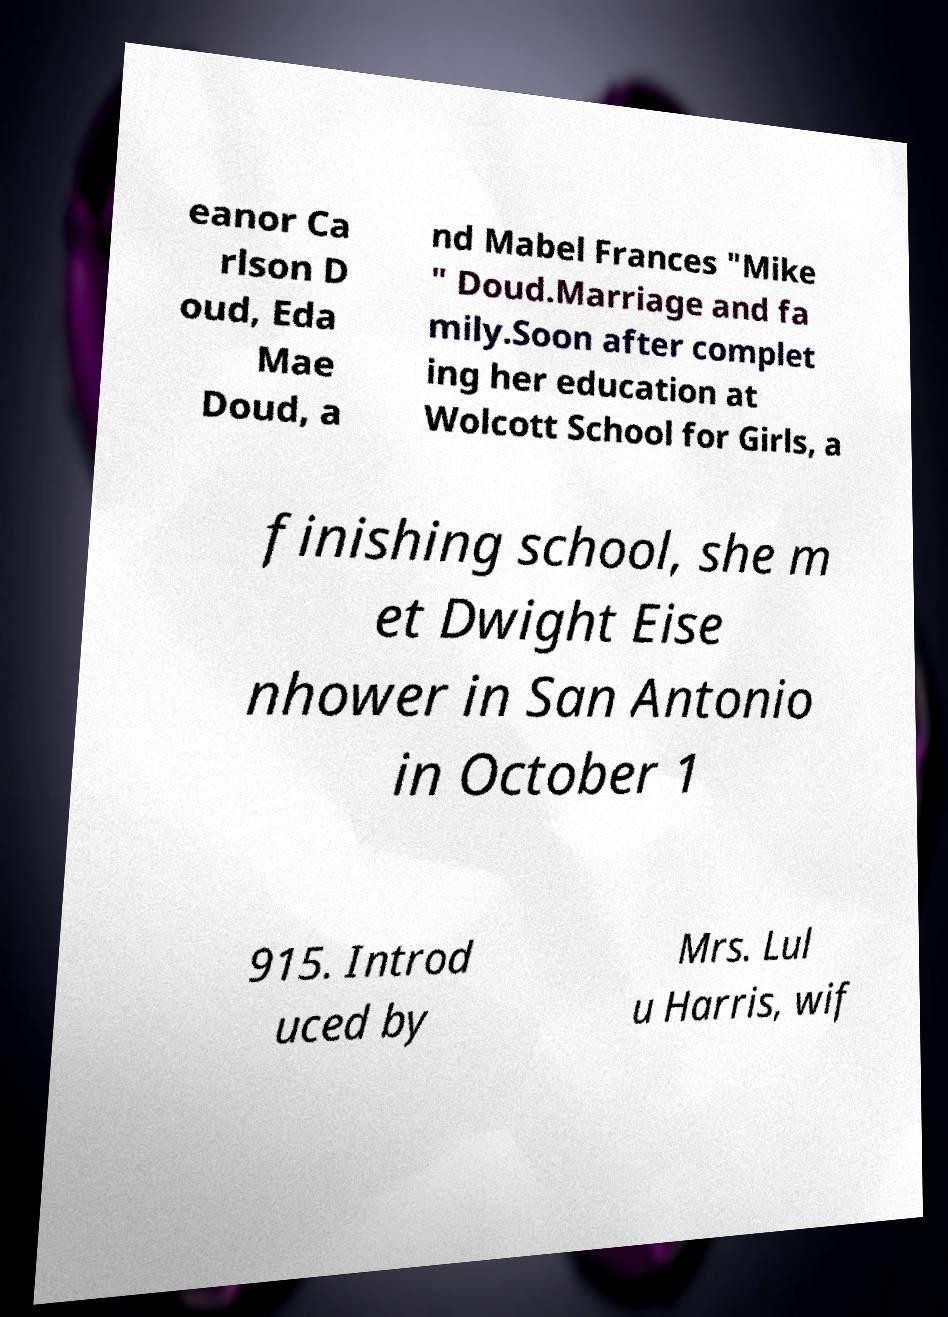Can you accurately transcribe the text from the provided image for me? eanor Ca rlson D oud, Eda Mae Doud, a nd Mabel Frances "Mike " Doud.Marriage and fa mily.Soon after complet ing her education at Wolcott School for Girls, a finishing school, she m et Dwight Eise nhower in San Antonio in October 1 915. Introd uced by Mrs. Lul u Harris, wif 